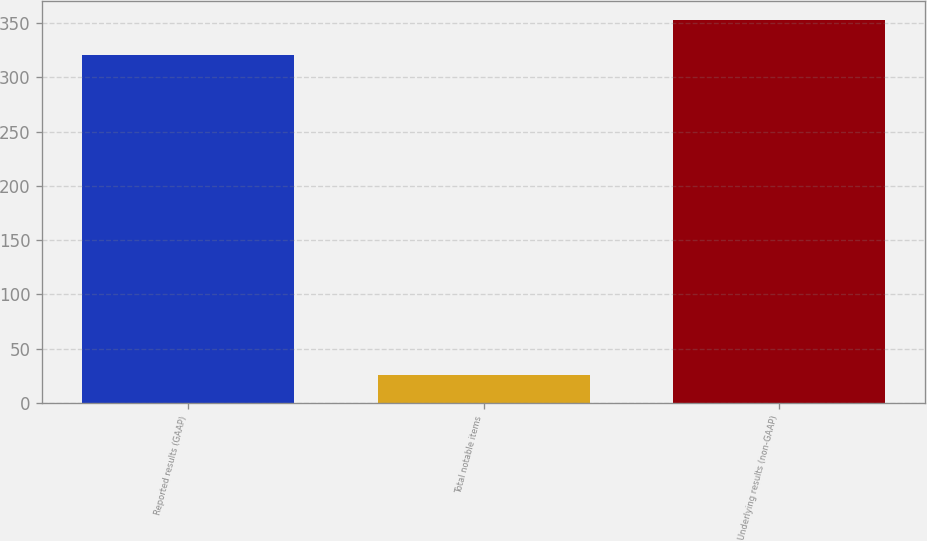Convert chart. <chart><loc_0><loc_0><loc_500><loc_500><bar_chart><fcel>Reported results (GAAP)<fcel>Total notable items<fcel>Underlying results (non-GAAP)<nl><fcel>321<fcel>26<fcel>353.1<nl></chart> 